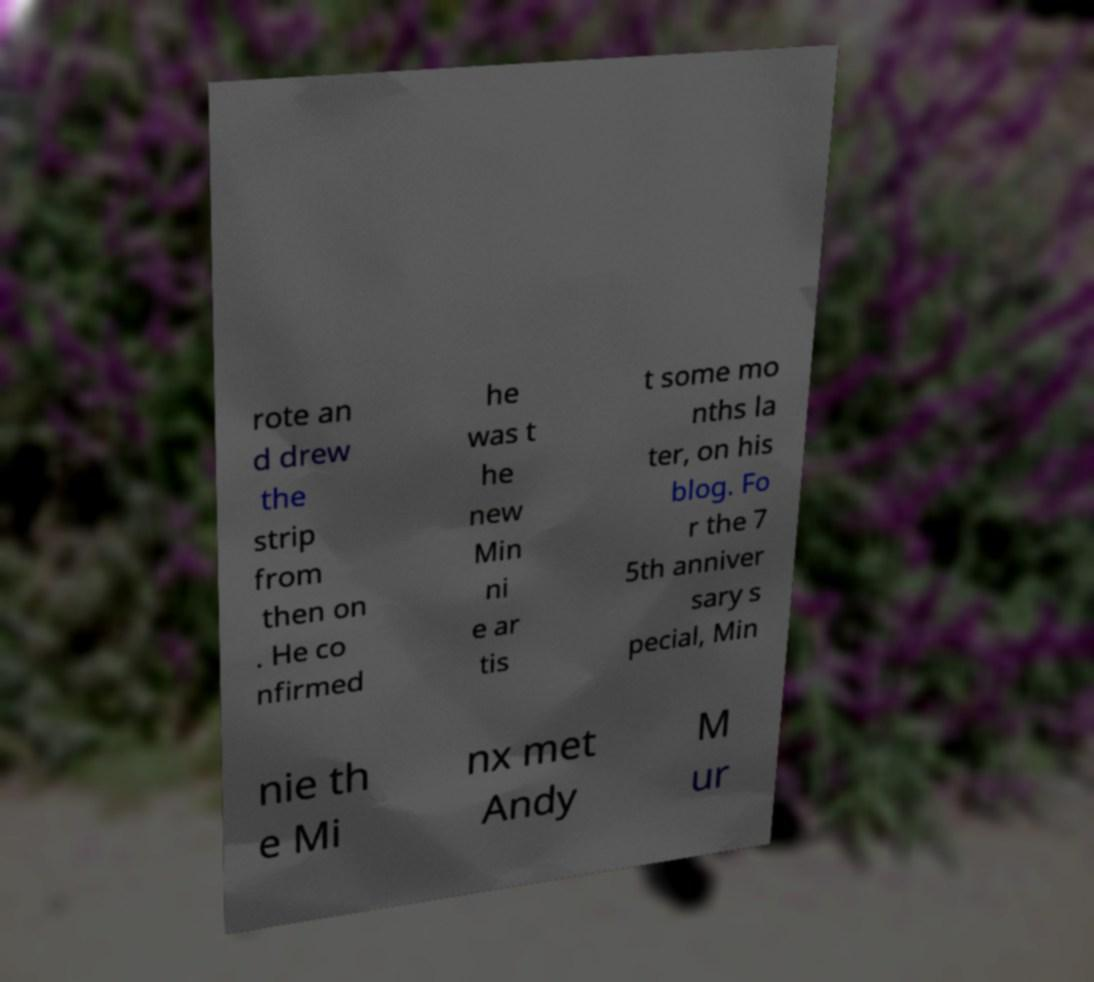There's text embedded in this image that I need extracted. Can you transcribe it verbatim? rote an d drew the strip from then on . He co nfirmed he was t he new Min ni e ar tis t some mo nths la ter, on his blog. Fo r the 7 5th anniver sary s pecial, Min nie th e Mi nx met Andy M ur 